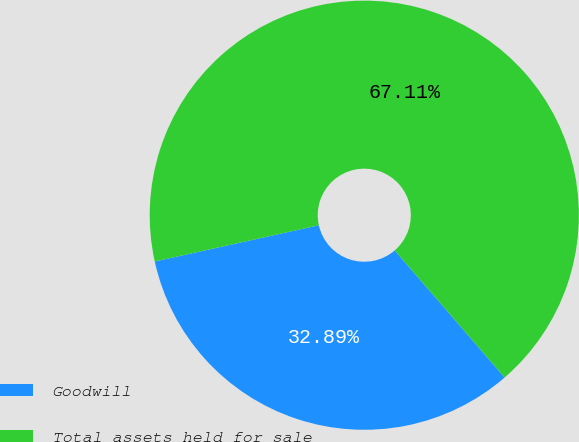Convert chart. <chart><loc_0><loc_0><loc_500><loc_500><pie_chart><fcel>Goodwill<fcel>Total assets held for sale<nl><fcel>32.89%<fcel>67.11%<nl></chart> 